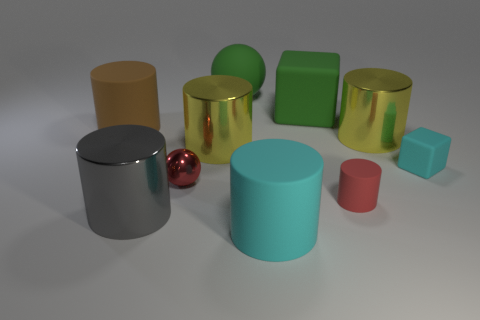What is the color of the tiny cube on the right side of the shiny thing in front of the tiny rubber thing that is on the left side of the small cube?
Your answer should be very brief. Cyan. How many other things are the same shape as the brown rubber thing?
Make the answer very short. 5. Is there a red metallic sphere that is right of the big matte ball on the right side of the small shiny ball?
Provide a succinct answer. No. How many matte things are either tiny cyan objects or red cylinders?
Offer a terse response. 2. What material is the large object that is both right of the large brown thing and to the left of the small ball?
Your response must be concise. Metal. Are there any green cubes that are behind the big green matte object to the left of the cyan object that is in front of the metal ball?
Your response must be concise. No. Is there any other thing that has the same material as the large cube?
Your response must be concise. Yes. There is a big brown thing that is made of the same material as the big green block; what shape is it?
Your answer should be compact. Cylinder. Is the number of large cubes that are in front of the red rubber cylinder less than the number of big yellow things that are behind the big gray cylinder?
Offer a terse response. Yes. How many big objects are either yellow metal objects or cyan matte cubes?
Provide a succinct answer. 2. 